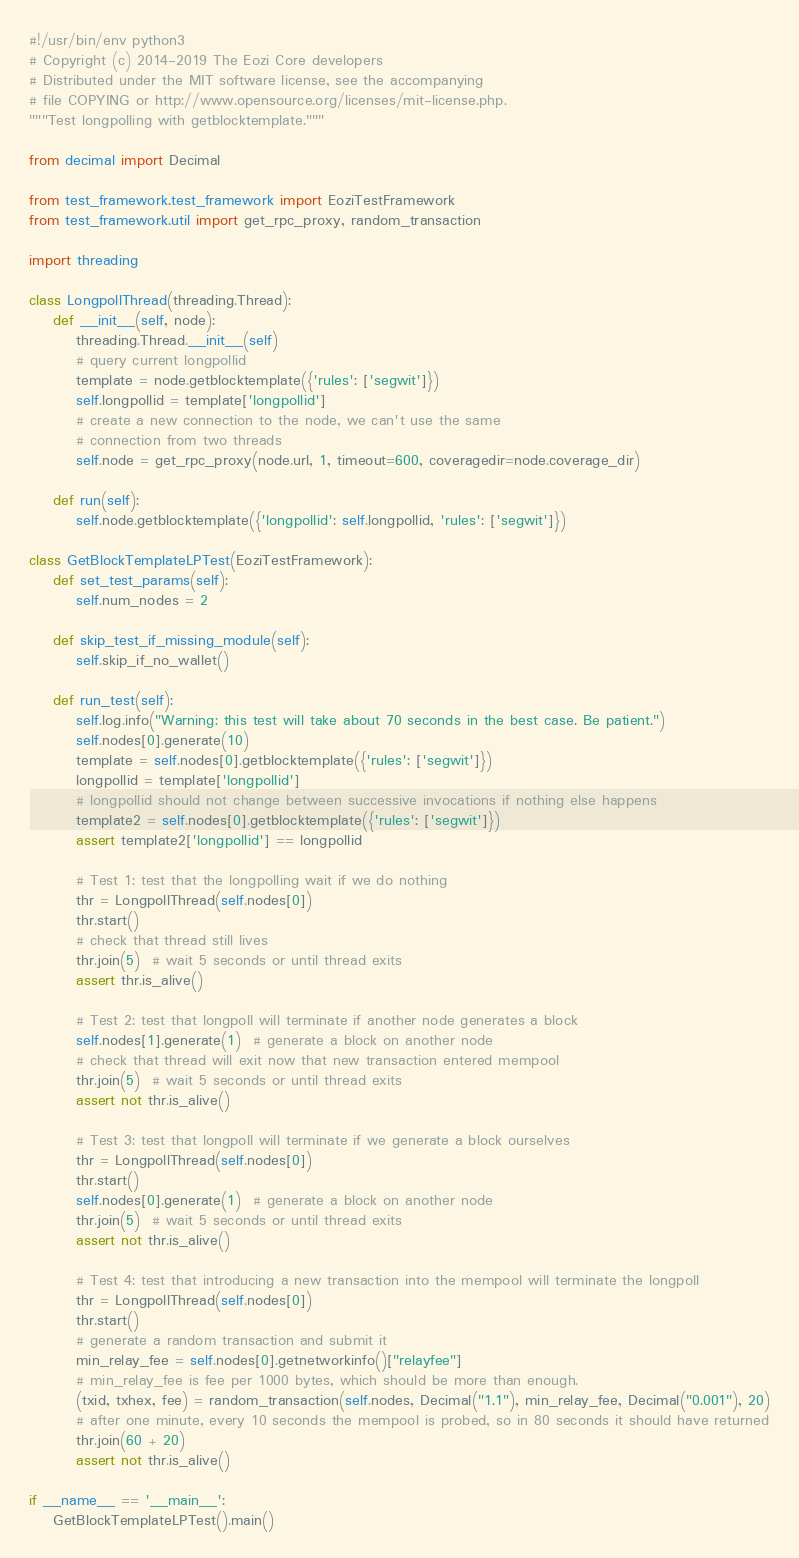Convert code to text. <code><loc_0><loc_0><loc_500><loc_500><_Python_>#!/usr/bin/env python3
# Copyright (c) 2014-2019 The Eozi Core developers
# Distributed under the MIT software license, see the accompanying
# file COPYING or http://www.opensource.org/licenses/mit-license.php.
"""Test longpolling with getblocktemplate."""

from decimal import Decimal

from test_framework.test_framework import EoziTestFramework
from test_framework.util import get_rpc_proxy, random_transaction

import threading

class LongpollThread(threading.Thread):
    def __init__(self, node):
        threading.Thread.__init__(self)
        # query current longpollid
        template = node.getblocktemplate({'rules': ['segwit']})
        self.longpollid = template['longpollid']
        # create a new connection to the node, we can't use the same
        # connection from two threads
        self.node = get_rpc_proxy(node.url, 1, timeout=600, coveragedir=node.coverage_dir)

    def run(self):
        self.node.getblocktemplate({'longpollid': self.longpollid, 'rules': ['segwit']})

class GetBlockTemplateLPTest(EoziTestFramework):
    def set_test_params(self):
        self.num_nodes = 2

    def skip_test_if_missing_module(self):
        self.skip_if_no_wallet()

    def run_test(self):
        self.log.info("Warning: this test will take about 70 seconds in the best case. Be patient.")
        self.nodes[0].generate(10)
        template = self.nodes[0].getblocktemplate({'rules': ['segwit']})
        longpollid = template['longpollid']
        # longpollid should not change between successive invocations if nothing else happens
        template2 = self.nodes[0].getblocktemplate({'rules': ['segwit']})
        assert template2['longpollid'] == longpollid

        # Test 1: test that the longpolling wait if we do nothing
        thr = LongpollThread(self.nodes[0])
        thr.start()
        # check that thread still lives
        thr.join(5)  # wait 5 seconds or until thread exits
        assert thr.is_alive()

        # Test 2: test that longpoll will terminate if another node generates a block
        self.nodes[1].generate(1)  # generate a block on another node
        # check that thread will exit now that new transaction entered mempool
        thr.join(5)  # wait 5 seconds or until thread exits
        assert not thr.is_alive()

        # Test 3: test that longpoll will terminate if we generate a block ourselves
        thr = LongpollThread(self.nodes[0])
        thr.start()
        self.nodes[0].generate(1)  # generate a block on another node
        thr.join(5)  # wait 5 seconds or until thread exits
        assert not thr.is_alive()

        # Test 4: test that introducing a new transaction into the mempool will terminate the longpoll
        thr = LongpollThread(self.nodes[0])
        thr.start()
        # generate a random transaction and submit it
        min_relay_fee = self.nodes[0].getnetworkinfo()["relayfee"]
        # min_relay_fee is fee per 1000 bytes, which should be more than enough.
        (txid, txhex, fee) = random_transaction(self.nodes, Decimal("1.1"), min_relay_fee, Decimal("0.001"), 20)
        # after one minute, every 10 seconds the mempool is probed, so in 80 seconds it should have returned
        thr.join(60 + 20)
        assert not thr.is_alive()

if __name__ == '__main__':
    GetBlockTemplateLPTest().main()
</code> 